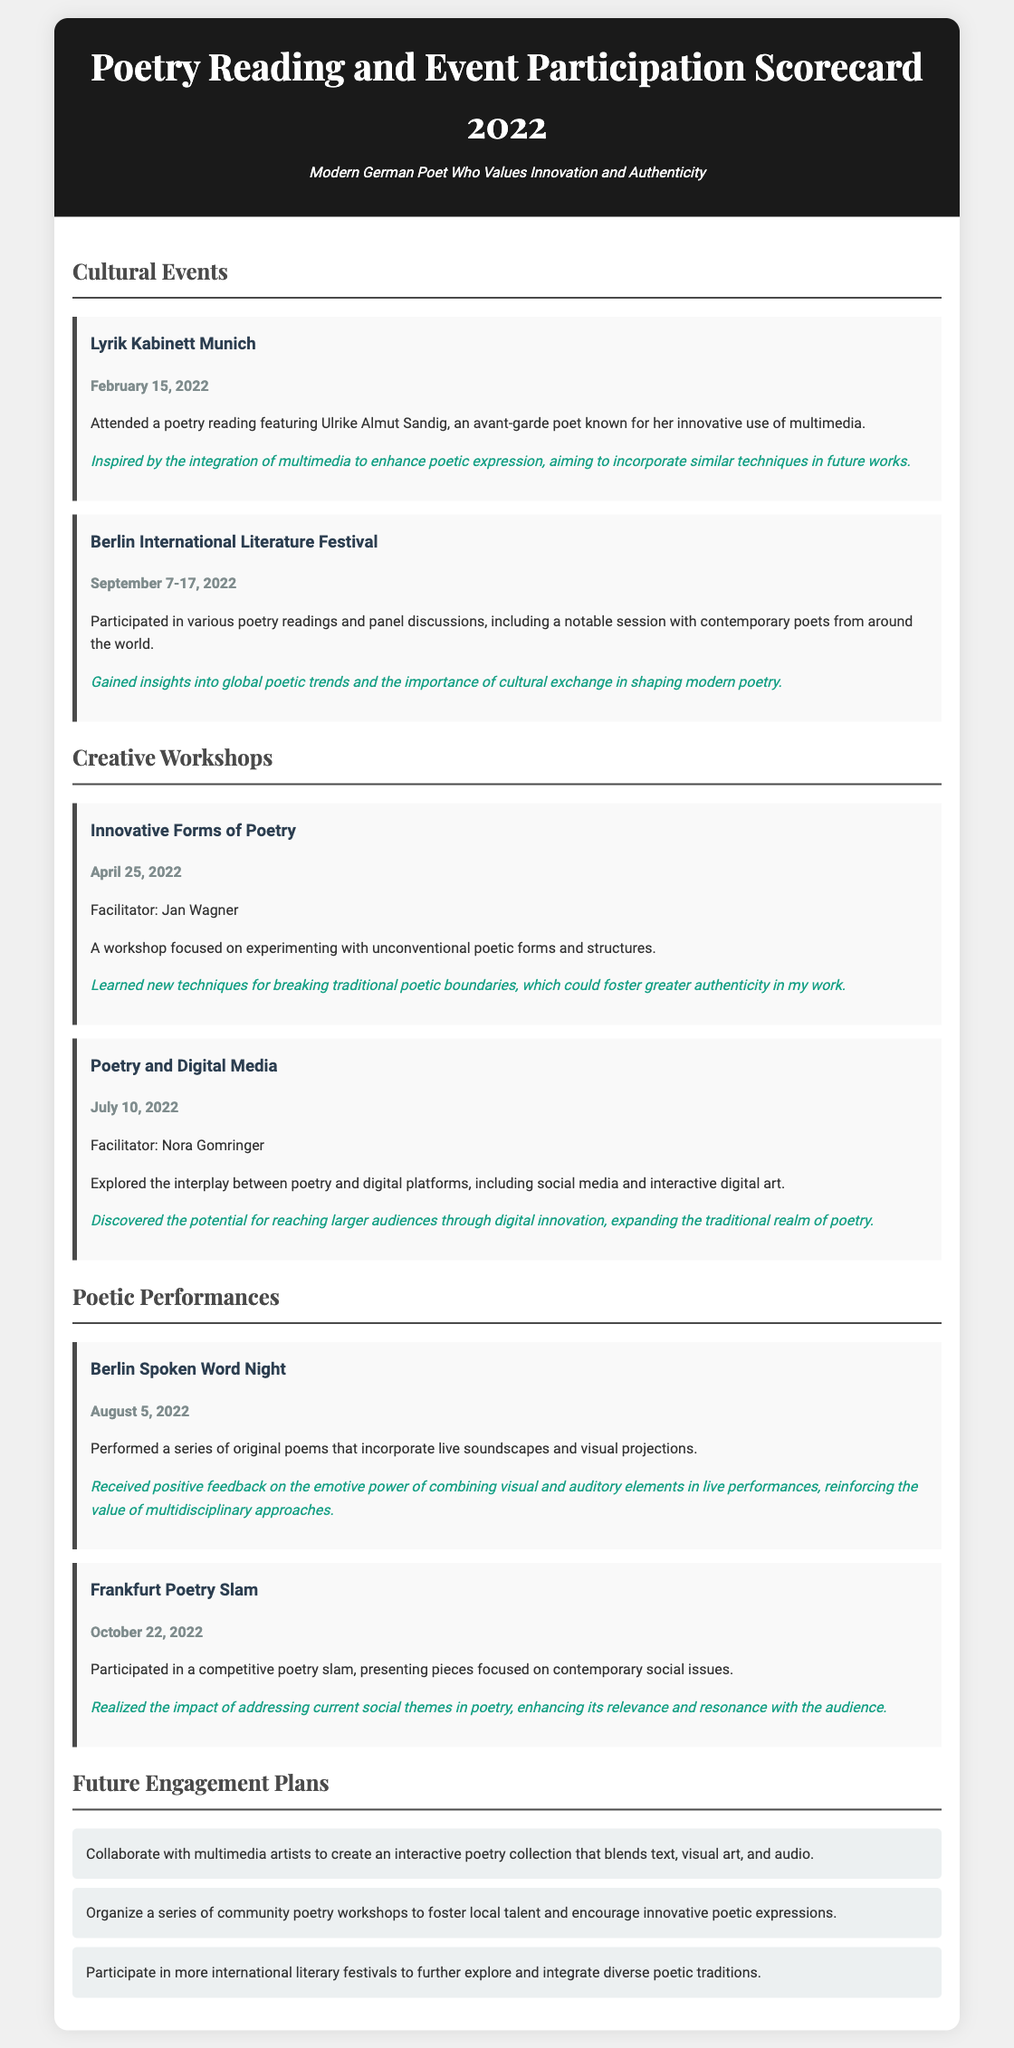What is the date of the Lyrik Kabinett event? The date is specified under the event title in the document.
Answer: February 15, 2022 Who was the facilitator of the "Poetry and Digital Media" workshop? The facilitator's name is indicated in the workshop section of the document.
Answer: Nora Gomringer How many cultural events are listed in the document? The document specifies the total number of cultural events in the events section.
Answer: Two What is one key learning from the Berlin International Literature Festival? Key learnings are shared after each event description.
Answer: Gained insights into global poetic trends What is a future engagement plan mentioned in the document? Future plans are listed at the end of the document, outlining intended actions.
Answer: Collaborate with multimedia artists How did the audience react to the performance at the Berlin Spoken Word Night? Audience feedback is mentioned as a learning point in the performance section.
Answer: Positive feedback What type of event was the Frankfurt Poetry Slam? The type of event is stated in the description of the related performance in the document.
Answer: Competitive poetry slam Which workshop focused on unconventional poetic forms? The specific workshop is identified under the Creative Workshops section.
Answer: Innovative Forms of Poetry 